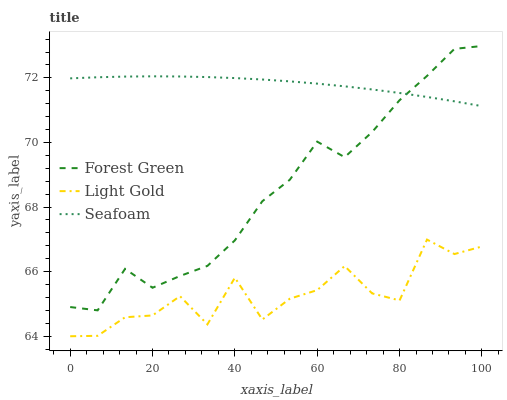Does Light Gold have the minimum area under the curve?
Answer yes or no. Yes. Does Seafoam have the maximum area under the curve?
Answer yes or no. Yes. Does Seafoam have the minimum area under the curve?
Answer yes or no. No. Does Light Gold have the maximum area under the curve?
Answer yes or no. No. Is Seafoam the smoothest?
Answer yes or no. Yes. Is Light Gold the roughest?
Answer yes or no. Yes. Is Light Gold the smoothest?
Answer yes or no. No. Is Seafoam the roughest?
Answer yes or no. No. Does Light Gold have the lowest value?
Answer yes or no. Yes. Does Seafoam have the lowest value?
Answer yes or no. No. Does Forest Green have the highest value?
Answer yes or no. Yes. Does Seafoam have the highest value?
Answer yes or no. No. Is Light Gold less than Forest Green?
Answer yes or no. Yes. Is Forest Green greater than Light Gold?
Answer yes or no. Yes. Does Forest Green intersect Seafoam?
Answer yes or no. Yes. Is Forest Green less than Seafoam?
Answer yes or no. No. Is Forest Green greater than Seafoam?
Answer yes or no. No. Does Light Gold intersect Forest Green?
Answer yes or no. No. 